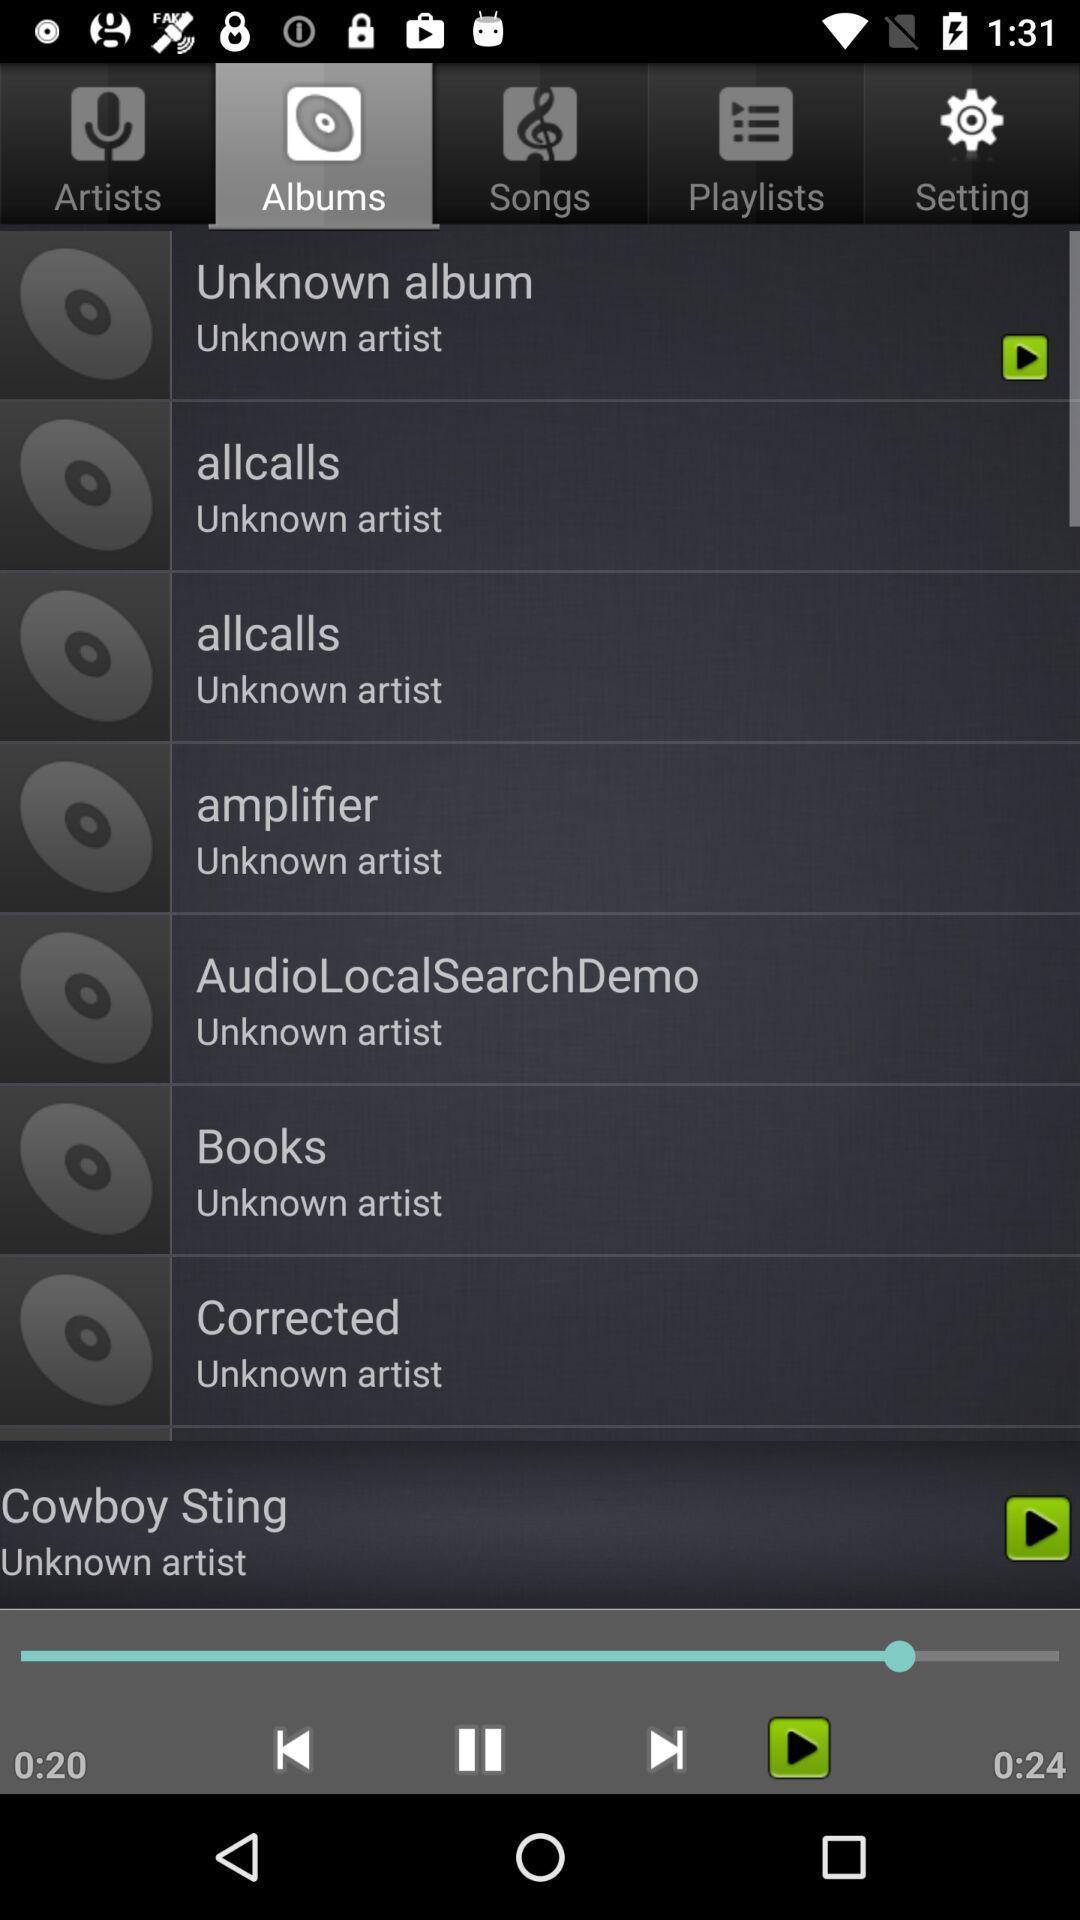Tell me about the visual elements in this screen capture. Screen page displaying different options in music application. 